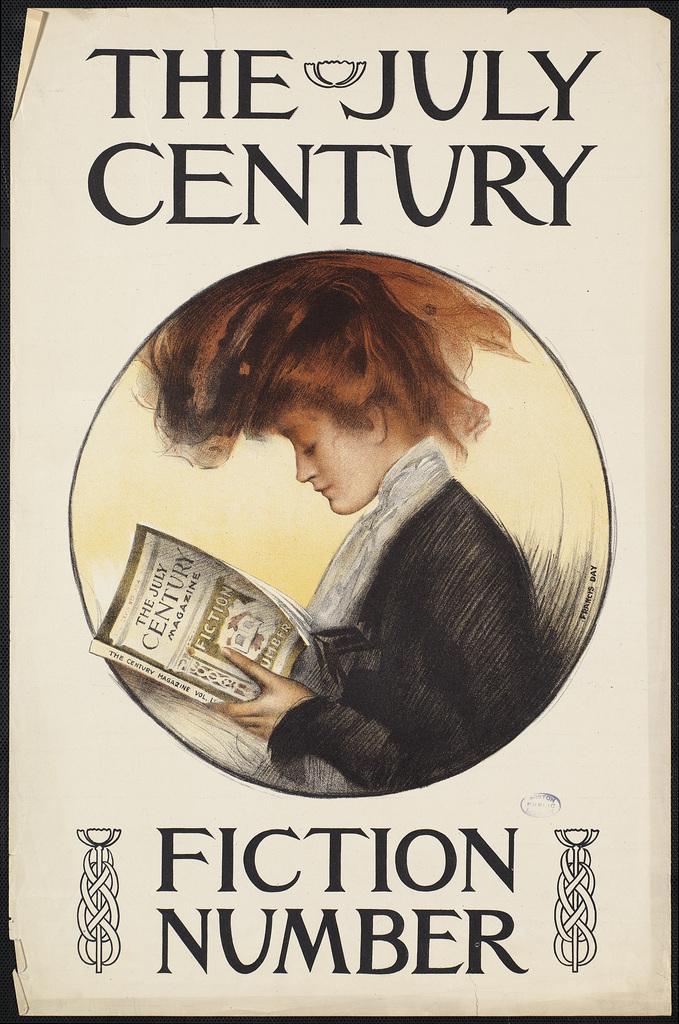What month is the century on the book cover?
Offer a terse response. July. What is the title of this book?
Keep it short and to the point. The july century. 